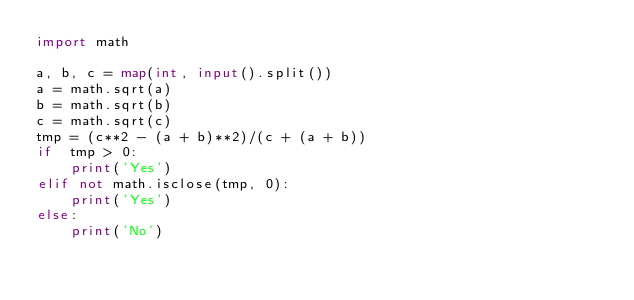<code> <loc_0><loc_0><loc_500><loc_500><_Python_>import math

a, b, c = map(int, input().split())
a = math.sqrt(a)
b = math.sqrt(b)
c = math.sqrt(c)
tmp = (c**2 - (a + b)**2)/(c + (a + b))
if  tmp > 0:
    print('Yes')
elif not math.isclose(tmp, 0):
    print('Yes')
else:
    print('No')</code> 